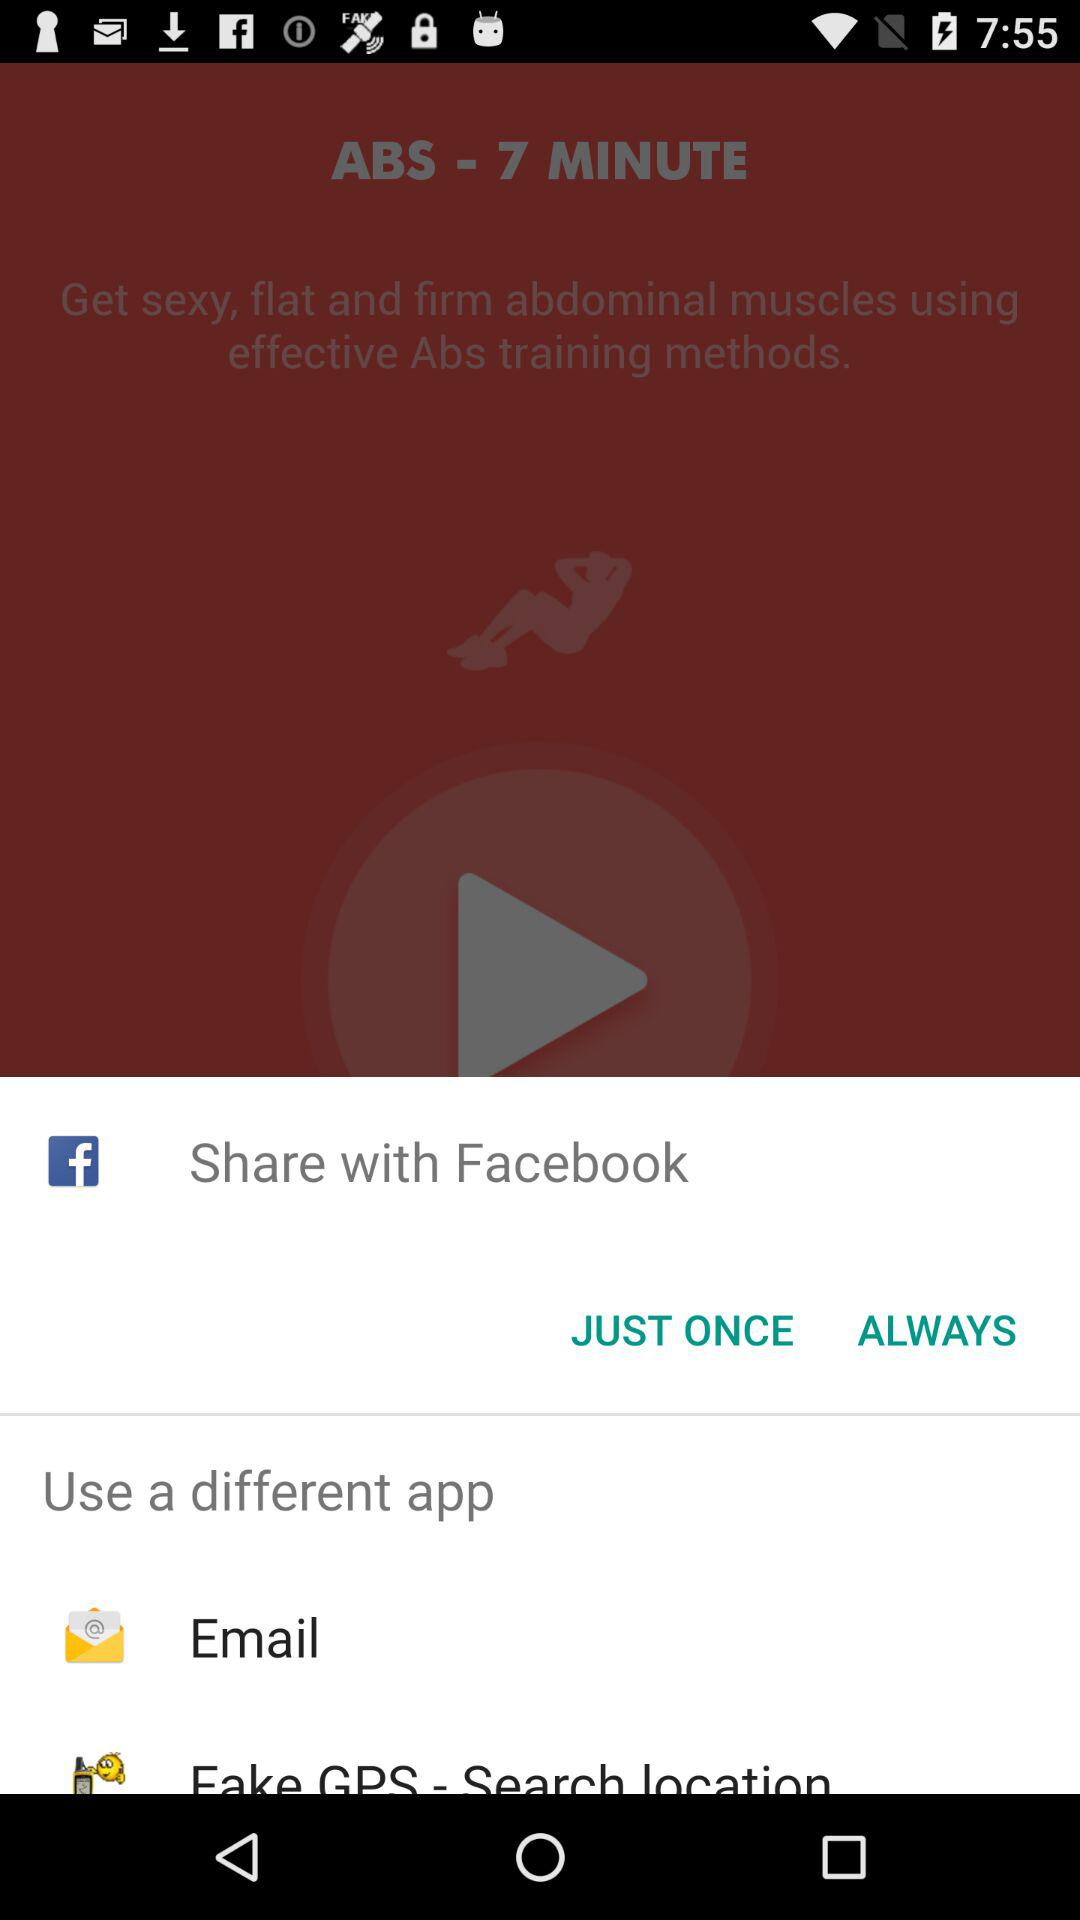Which applications can I use to share? The applications are "Facebook", "Email" and "Fake GPS - Search location". 